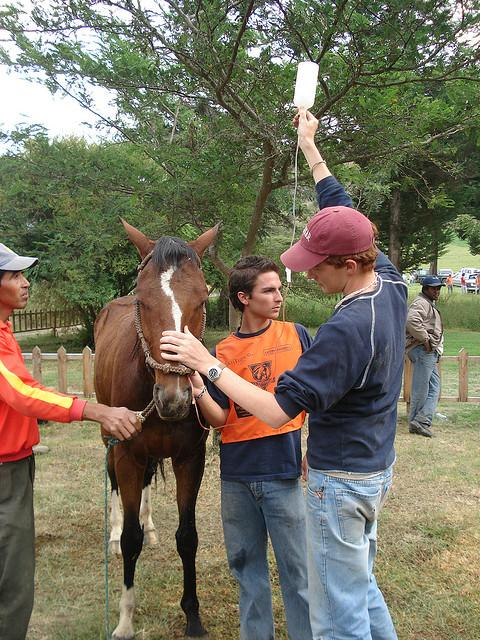What item is held up by the man here?

Choices:
A) iv bag
B) poison
C) milk bottle
D) whiskey iv bag 